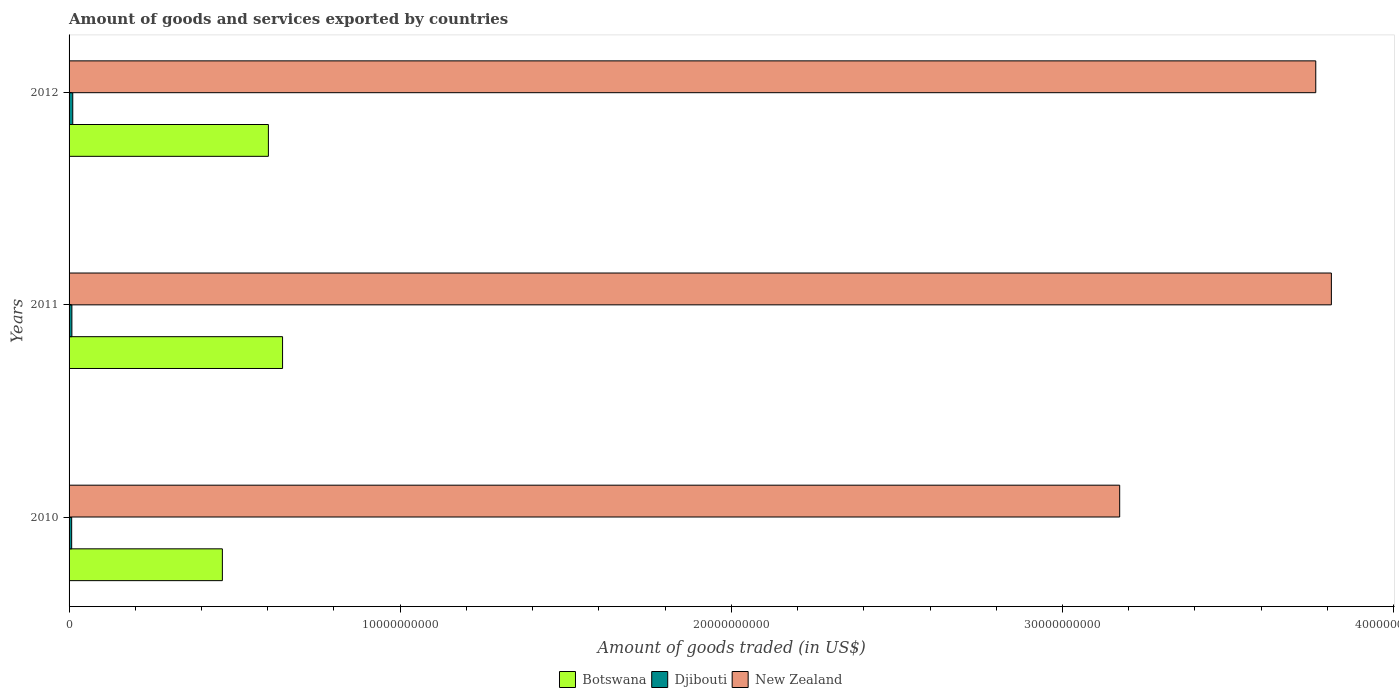Are the number of bars on each tick of the Y-axis equal?
Make the answer very short. Yes. How many bars are there on the 1st tick from the bottom?
Ensure brevity in your answer.  3. What is the label of the 2nd group of bars from the top?
Your answer should be very brief. 2011. In how many cases, is the number of bars for a given year not equal to the number of legend labels?
Make the answer very short. 0. What is the total amount of goods and services exported in New Zealand in 2012?
Offer a very short reply. 3.76e+1. Across all years, what is the maximum total amount of goods and services exported in New Zealand?
Your answer should be very brief. 3.81e+1. Across all years, what is the minimum total amount of goods and services exported in New Zealand?
Provide a succinct answer. 3.17e+1. In which year was the total amount of goods and services exported in Botswana minimum?
Offer a very short reply. 2010. What is the total total amount of goods and services exported in Botswana in the graph?
Offer a terse response. 1.71e+1. What is the difference between the total amount of goods and services exported in Botswana in 2010 and that in 2012?
Make the answer very short. -1.39e+09. What is the difference between the total amount of goods and services exported in New Zealand in 2011 and the total amount of goods and services exported in Djibouti in 2012?
Give a very brief answer. 3.80e+1. What is the average total amount of goods and services exported in Djibouti per year?
Keep it short and to the point. 9.17e+07. In the year 2012, what is the difference between the total amount of goods and services exported in New Zealand and total amount of goods and services exported in Botswana?
Your response must be concise. 3.16e+1. What is the ratio of the total amount of goods and services exported in Djibouti in 2010 to that in 2012?
Offer a very short reply. 0.71. Is the difference between the total amount of goods and services exported in New Zealand in 2011 and 2012 greater than the difference between the total amount of goods and services exported in Botswana in 2011 and 2012?
Provide a succinct answer. Yes. What is the difference between the highest and the second highest total amount of goods and services exported in New Zealand?
Provide a succinct answer. 4.72e+08. What is the difference between the highest and the lowest total amount of goods and services exported in Botswana?
Provide a short and direct response. 1.82e+09. In how many years, is the total amount of goods and services exported in Djibouti greater than the average total amount of goods and services exported in Djibouti taken over all years?
Provide a succinct answer. 1. What does the 1st bar from the top in 2011 represents?
Make the answer very short. New Zealand. What does the 3rd bar from the bottom in 2010 represents?
Ensure brevity in your answer.  New Zealand. Is it the case that in every year, the sum of the total amount of goods and services exported in Botswana and total amount of goods and services exported in New Zealand is greater than the total amount of goods and services exported in Djibouti?
Your answer should be very brief. Yes. How many bars are there?
Ensure brevity in your answer.  9. Are all the bars in the graph horizontal?
Provide a short and direct response. Yes. Where does the legend appear in the graph?
Your answer should be very brief. Bottom center. How many legend labels are there?
Make the answer very short. 3. What is the title of the graph?
Your answer should be very brief. Amount of goods and services exported by countries. Does "Zambia" appear as one of the legend labels in the graph?
Provide a short and direct response. No. What is the label or title of the X-axis?
Your answer should be very brief. Amount of goods traded (in US$). What is the Amount of goods traded (in US$) in Botswana in 2010?
Your response must be concise. 4.63e+09. What is the Amount of goods traded (in US$) in Djibouti in 2010?
Ensure brevity in your answer.  7.87e+07. What is the Amount of goods traded (in US$) of New Zealand in 2010?
Ensure brevity in your answer.  3.17e+1. What is the Amount of goods traded (in US$) in Botswana in 2011?
Offer a very short reply. 6.45e+09. What is the Amount of goods traded (in US$) in Djibouti in 2011?
Keep it short and to the point. 8.50e+07. What is the Amount of goods traded (in US$) in New Zealand in 2011?
Keep it short and to the point. 3.81e+1. What is the Amount of goods traded (in US$) in Botswana in 2012?
Ensure brevity in your answer.  6.02e+09. What is the Amount of goods traded (in US$) of Djibouti in 2012?
Ensure brevity in your answer.  1.11e+08. What is the Amount of goods traded (in US$) in New Zealand in 2012?
Give a very brief answer. 3.76e+1. Across all years, what is the maximum Amount of goods traded (in US$) of Botswana?
Provide a succinct answer. 6.45e+09. Across all years, what is the maximum Amount of goods traded (in US$) of Djibouti?
Your answer should be compact. 1.11e+08. Across all years, what is the maximum Amount of goods traded (in US$) in New Zealand?
Offer a terse response. 3.81e+1. Across all years, what is the minimum Amount of goods traded (in US$) in Botswana?
Your answer should be compact. 4.63e+09. Across all years, what is the minimum Amount of goods traded (in US$) of Djibouti?
Offer a terse response. 7.87e+07. Across all years, what is the minimum Amount of goods traded (in US$) of New Zealand?
Offer a very short reply. 3.17e+1. What is the total Amount of goods traded (in US$) of Botswana in the graph?
Make the answer very short. 1.71e+1. What is the total Amount of goods traded (in US$) of Djibouti in the graph?
Your answer should be very brief. 2.75e+08. What is the total Amount of goods traded (in US$) in New Zealand in the graph?
Ensure brevity in your answer.  1.07e+11. What is the difference between the Amount of goods traded (in US$) of Botswana in 2010 and that in 2011?
Provide a short and direct response. -1.82e+09. What is the difference between the Amount of goods traded (in US$) of Djibouti in 2010 and that in 2011?
Your response must be concise. -6.30e+06. What is the difference between the Amount of goods traded (in US$) of New Zealand in 2010 and that in 2011?
Offer a very short reply. -6.39e+09. What is the difference between the Amount of goods traded (in US$) of Botswana in 2010 and that in 2012?
Keep it short and to the point. -1.39e+09. What is the difference between the Amount of goods traded (in US$) in Djibouti in 2010 and that in 2012?
Your response must be concise. -3.27e+07. What is the difference between the Amount of goods traded (in US$) in New Zealand in 2010 and that in 2012?
Your response must be concise. -5.92e+09. What is the difference between the Amount of goods traded (in US$) of Botswana in 2011 and that in 2012?
Keep it short and to the point. 4.28e+08. What is the difference between the Amount of goods traded (in US$) of Djibouti in 2011 and that in 2012?
Keep it short and to the point. -2.64e+07. What is the difference between the Amount of goods traded (in US$) of New Zealand in 2011 and that in 2012?
Provide a succinct answer. 4.72e+08. What is the difference between the Amount of goods traded (in US$) of Botswana in 2010 and the Amount of goods traded (in US$) of Djibouti in 2011?
Offer a very short reply. 4.54e+09. What is the difference between the Amount of goods traded (in US$) in Botswana in 2010 and the Amount of goods traded (in US$) in New Zealand in 2011?
Ensure brevity in your answer.  -3.35e+1. What is the difference between the Amount of goods traded (in US$) in Djibouti in 2010 and the Amount of goods traded (in US$) in New Zealand in 2011?
Ensure brevity in your answer.  -3.80e+1. What is the difference between the Amount of goods traded (in US$) of Botswana in 2010 and the Amount of goods traded (in US$) of Djibouti in 2012?
Your answer should be compact. 4.52e+09. What is the difference between the Amount of goods traded (in US$) in Botswana in 2010 and the Amount of goods traded (in US$) in New Zealand in 2012?
Offer a terse response. -3.30e+1. What is the difference between the Amount of goods traded (in US$) in Djibouti in 2010 and the Amount of goods traded (in US$) in New Zealand in 2012?
Provide a succinct answer. -3.76e+1. What is the difference between the Amount of goods traded (in US$) in Botswana in 2011 and the Amount of goods traded (in US$) in Djibouti in 2012?
Provide a succinct answer. 6.34e+09. What is the difference between the Amount of goods traded (in US$) in Botswana in 2011 and the Amount of goods traded (in US$) in New Zealand in 2012?
Your response must be concise. -3.12e+1. What is the difference between the Amount of goods traded (in US$) in Djibouti in 2011 and the Amount of goods traded (in US$) in New Zealand in 2012?
Offer a terse response. -3.76e+1. What is the average Amount of goods traded (in US$) in Botswana per year?
Offer a very short reply. 5.70e+09. What is the average Amount of goods traded (in US$) in Djibouti per year?
Your answer should be very brief. 9.17e+07. What is the average Amount of goods traded (in US$) of New Zealand per year?
Your answer should be very brief. 3.58e+1. In the year 2010, what is the difference between the Amount of goods traded (in US$) of Botswana and Amount of goods traded (in US$) of Djibouti?
Make the answer very short. 4.55e+09. In the year 2010, what is the difference between the Amount of goods traded (in US$) of Botswana and Amount of goods traded (in US$) of New Zealand?
Your answer should be compact. -2.71e+1. In the year 2010, what is the difference between the Amount of goods traded (in US$) of Djibouti and Amount of goods traded (in US$) of New Zealand?
Provide a succinct answer. -3.16e+1. In the year 2011, what is the difference between the Amount of goods traded (in US$) of Botswana and Amount of goods traded (in US$) of Djibouti?
Offer a very short reply. 6.36e+09. In the year 2011, what is the difference between the Amount of goods traded (in US$) of Botswana and Amount of goods traded (in US$) of New Zealand?
Keep it short and to the point. -3.17e+1. In the year 2011, what is the difference between the Amount of goods traded (in US$) in Djibouti and Amount of goods traded (in US$) in New Zealand?
Make the answer very short. -3.80e+1. In the year 2012, what is the difference between the Amount of goods traded (in US$) in Botswana and Amount of goods traded (in US$) in Djibouti?
Provide a short and direct response. 5.91e+09. In the year 2012, what is the difference between the Amount of goods traded (in US$) of Botswana and Amount of goods traded (in US$) of New Zealand?
Your answer should be very brief. -3.16e+1. In the year 2012, what is the difference between the Amount of goods traded (in US$) in Djibouti and Amount of goods traded (in US$) in New Zealand?
Offer a terse response. -3.75e+1. What is the ratio of the Amount of goods traded (in US$) of Botswana in 2010 to that in 2011?
Your answer should be very brief. 0.72. What is the ratio of the Amount of goods traded (in US$) of Djibouti in 2010 to that in 2011?
Provide a succinct answer. 0.93. What is the ratio of the Amount of goods traded (in US$) of New Zealand in 2010 to that in 2011?
Your answer should be very brief. 0.83. What is the ratio of the Amount of goods traded (in US$) in Botswana in 2010 to that in 2012?
Offer a terse response. 0.77. What is the ratio of the Amount of goods traded (in US$) in Djibouti in 2010 to that in 2012?
Offer a terse response. 0.71. What is the ratio of the Amount of goods traded (in US$) of New Zealand in 2010 to that in 2012?
Your response must be concise. 0.84. What is the ratio of the Amount of goods traded (in US$) in Botswana in 2011 to that in 2012?
Ensure brevity in your answer.  1.07. What is the ratio of the Amount of goods traded (in US$) of Djibouti in 2011 to that in 2012?
Make the answer very short. 0.76. What is the ratio of the Amount of goods traded (in US$) in New Zealand in 2011 to that in 2012?
Provide a succinct answer. 1.01. What is the difference between the highest and the second highest Amount of goods traded (in US$) of Botswana?
Your answer should be very brief. 4.28e+08. What is the difference between the highest and the second highest Amount of goods traded (in US$) of Djibouti?
Your answer should be very brief. 2.64e+07. What is the difference between the highest and the second highest Amount of goods traded (in US$) of New Zealand?
Your response must be concise. 4.72e+08. What is the difference between the highest and the lowest Amount of goods traded (in US$) in Botswana?
Give a very brief answer. 1.82e+09. What is the difference between the highest and the lowest Amount of goods traded (in US$) of Djibouti?
Provide a succinct answer. 3.27e+07. What is the difference between the highest and the lowest Amount of goods traded (in US$) in New Zealand?
Offer a very short reply. 6.39e+09. 